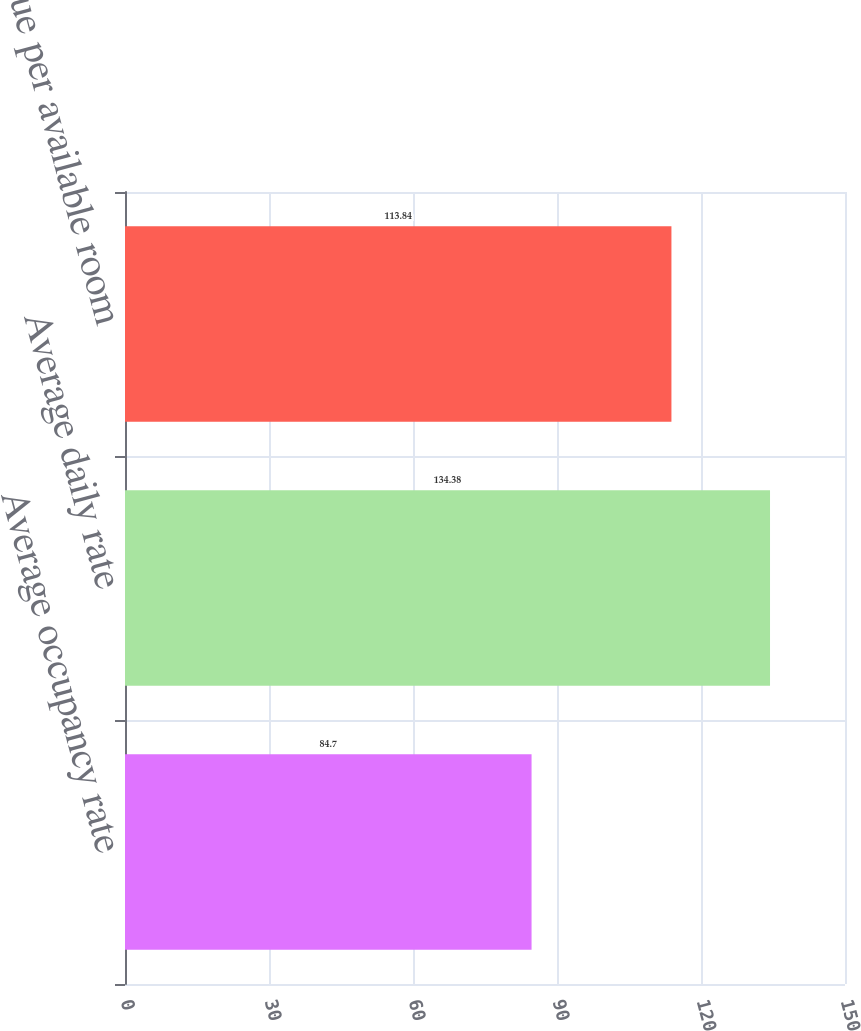Convert chart to OTSL. <chart><loc_0><loc_0><loc_500><loc_500><bar_chart><fcel>Average occupancy rate<fcel>Average daily rate<fcel>Revenue per available room<nl><fcel>84.7<fcel>134.38<fcel>113.84<nl></chart> 